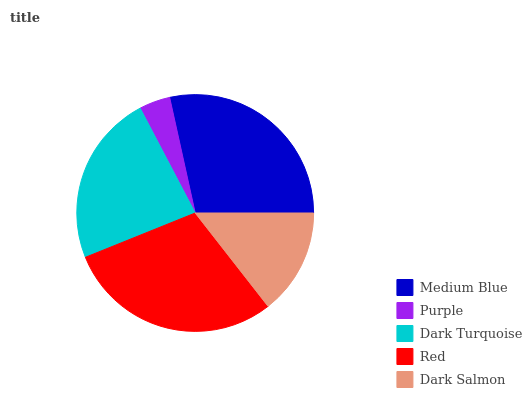Is Purple the minimum?
Answer yes or no. Yes. Is Red the maximum?
Answer yes or no. Yes. Is Dark Turquoise the minimum?
Answer yes or no. No. Is Dark Turquoise the maximum?
Answer yes or no. No. Is Dark Turquoise greater than Purple?
Answer yes or no. Yes. Is Purple less than Dark Turquoise?
Answer yes or no. Yes. Is Purple greater than Dark Turquoise?
Answer yes or no. No. Is Dark Turquoise less than Purple?
Answer yes or no. No. Is Dark Turquoise the high median?
Answer yes or no. Yes. Is Dark Turquoise the low median?
Answer yes or no. Yes. Is Dark Salmon the high median?
Answer yes or no. No. Is Purple the low median?
Answer yes or no. No. 